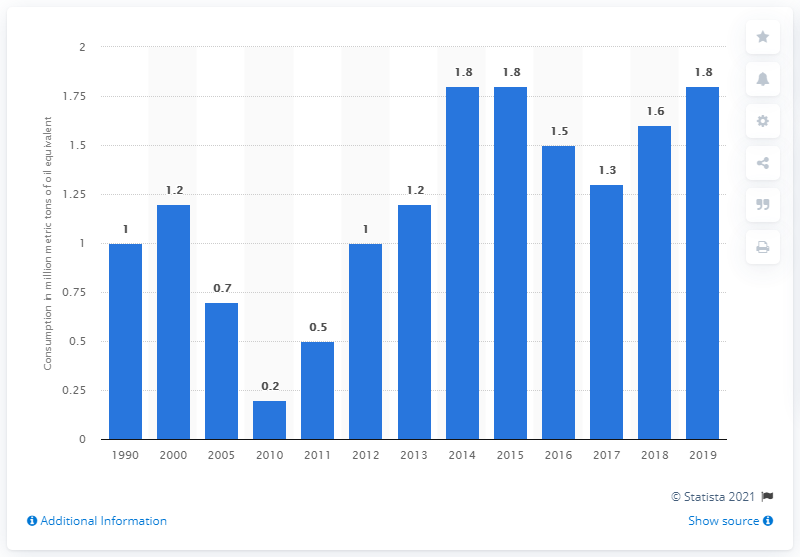Mention a couple of crucial points in this snapshot. The amount of oil equivalent imported in 2016 was 1.5... In 2019, net electricity imports amounted to 1.8 units of oil equivalent. 